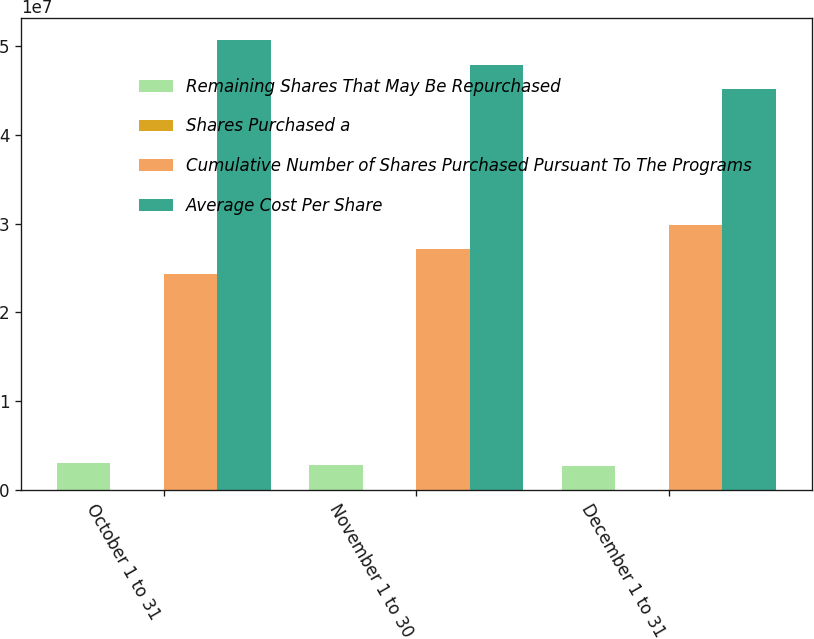Convert chart to OTSL. <chart><loc_0><loc_0><loc_500><loc_500><stacked_bar_chart><ecel><fcel>October 1 to 31<fcel>November 1 to 30<fcel>December 1 to 31<nl><fcel>Remaining Shares That May Be Repurchased<fcel>3.055e+06<fcel>2.838e+06<fcel>2.665e+06<nl><fcel>Shares Purchased a<fcel>57.56<fcel>58.42<fcel>59.4<nl><fcel>Cumulative Number of Shares Purchased Pursuant To The Programs<fcel>2.4328e+07<fcel>2.7166e+07<fcel>2.9831e+07<nl><fcel>Average Cost Per Share<fcel>5.0672e+07<fcel>4.7834e+07<fcel>4.5169e+07<nl></chart> 